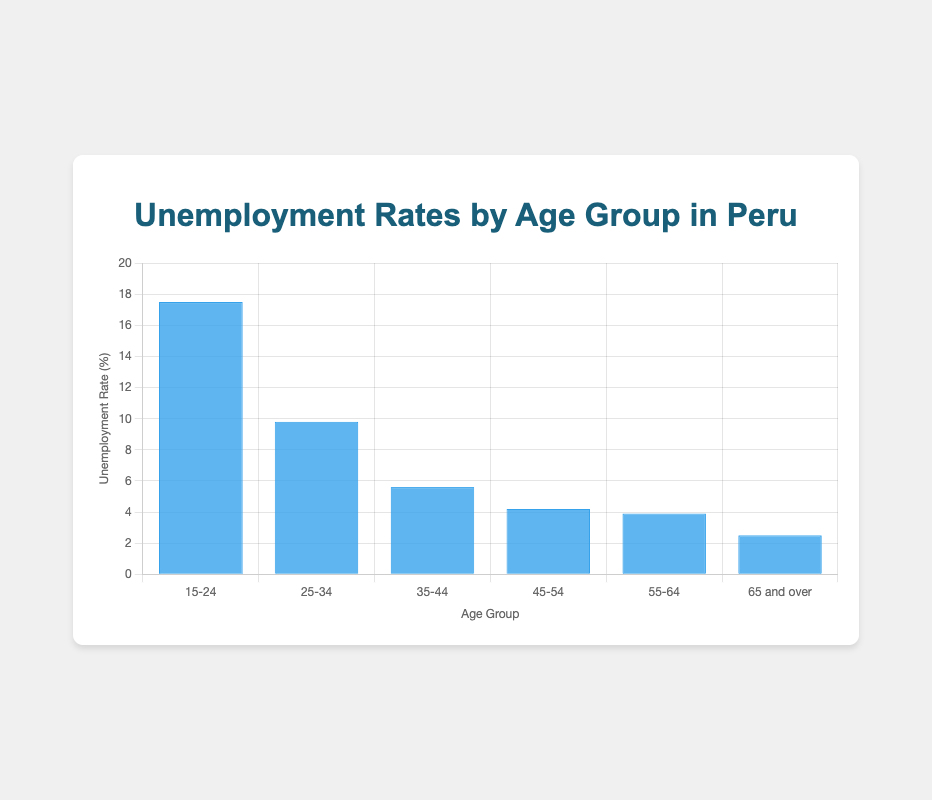What is the highest unemployment rate among all age groups? The highest bar represents the 15-24 age group with an unemployment rate of 17.5%. So, the highest unemployment rate is 17.5%.
Answer: 17.5% Which age group has the lowest unemployment rate? The shortest bar corresponds to the 65 and over age group, indicating the lowest unemployment rate of 2.5%.
Answer: 65 and over What is the difference in unemployment rates between the 15-24 and 55-64 age groups? The unemployment rate for 15-24 is 17.5% and for 55-64 is 3.9%. The difference is calculated as 17.5% - 3.9% = 13.6%.
Answer: 13.6% What is the average unemployment rate across all age groups? Sum the unemployment rates (17.5% + 9.8% + 5.6% + 4.2% + 3.9% + 2.5%) to get 43.5%. Divide by the number of age groups (6) to get 43.5%/6 ≈ 7.25%.
Answer: 7.25% Between which two adjacent age groups is the largest decrease in unemployment rate? Calculate the differences between adjacent groups: (17.5 - 9.8 = 7.7), (9.8 - 5.6 = 4.2), (5.6 - 4.2 = 1.4), (4.2 - 3.9 = 0.3), (3.9 - 2.5 = 1.4). The largest decrease is between 15-24 and 25-34 with a difference of 7.7%.
Answer: 15-24 and 25-34 How much higher is the unemployment rate for the 25-34 age group compared to the 45-54 age group? The unemployment rate for 25-34 is 9.8% and for 45-54 is 4.2%. The difference is 9.8% - 4.2% = 5.6%.
Answer: 5.6% What age group falls in the middle of the unemployment rate scale? When sorted by unemployment rate, the middle values (median) are 5.6% and 4.2%. The 35-44 age group with 5.6% is closer to the middle of the range.
Answer: 35-44 If the unemployment rate for the 25-34 group were to increase by 2%, what would the new rate be? The current rate for 25-34 is 9.8%. Adding 2% makes the new rate 9.8% + 2% = 11.8%.
Answer: 11.8% How would you describe the trend of unemployment rates as age increases? The unemployment rate decreases as age increases. This is visually evident as each subsequent age group's bar is shorter than the previous age group's bar.
Answer: Decreasing 